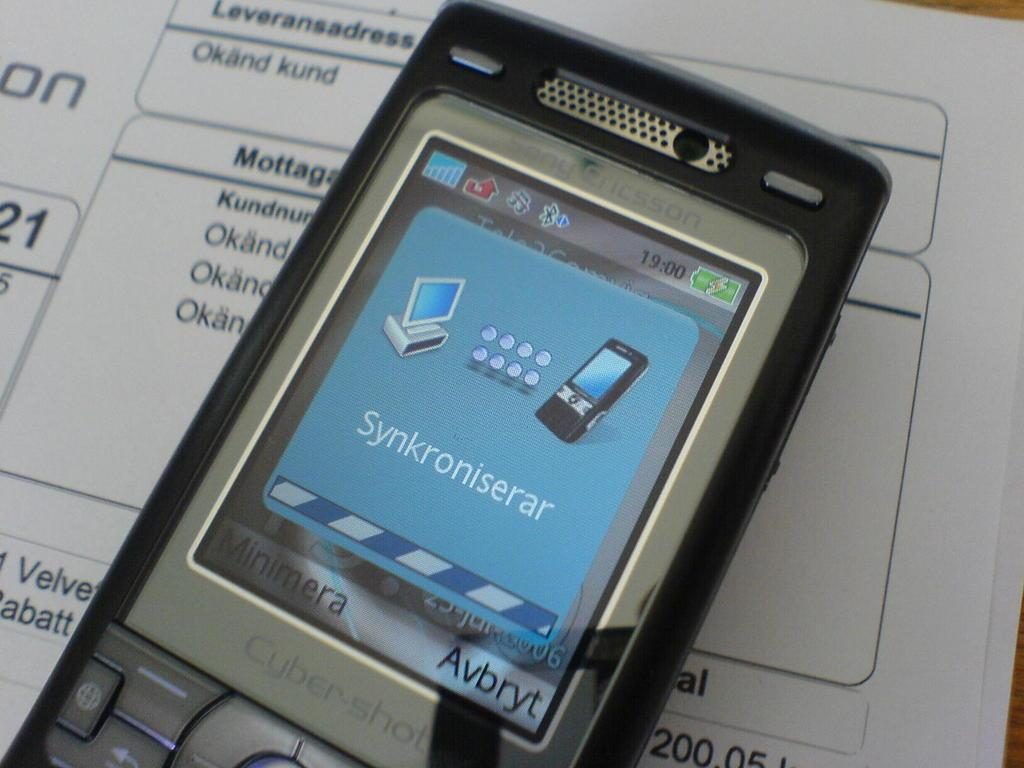Provide a one-sentence caption for the provided image. A phone screen showing the word Synkroniserar on it. 